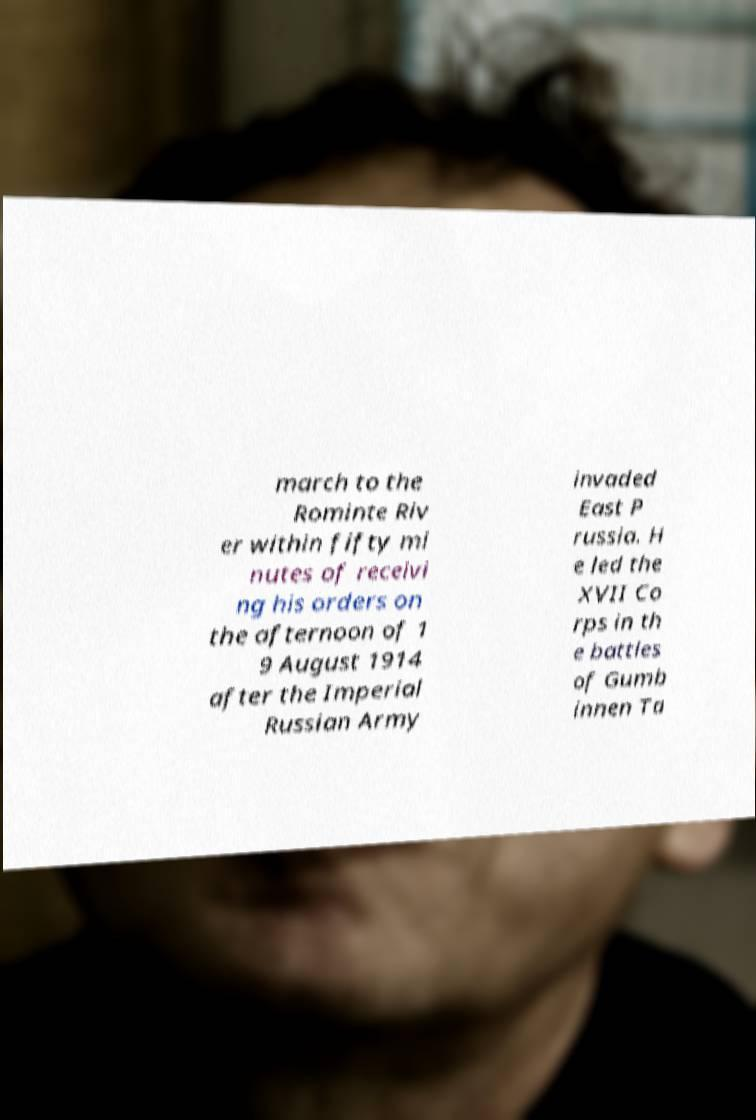There's text embedded in this image that I need extracted. Can you transcribe it verbatim? march to the Rominte Riv er within fifty mi nutes of receivi ng his orders on the afternoon of 1 9 August 1914 after the Imperial Russian Army invaded East P russia. H e led the XVII Co rps in th e battles of Gumb innen Ta 